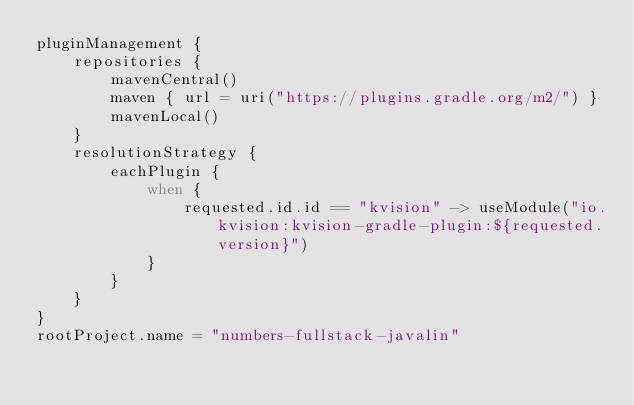<code> <loc_0><loc_0><loc_500><loc_500><_Kotlin_>pluginManagement {
    repositories {
        mavenCentral()
        maven { url = uri("https://plugins.gradle.org/m2/") }
        mavenLocal()
    }
    resolutionStrategy {
        eachPlugin {
            when {
                requested.id.id == "kvision" -> useModule("io.kvision:kvision-gradle-plugin:${requested.version}")
            }
        }
    }
}
rootProject.name = "numbers-fullstack-javalin"
</code> 